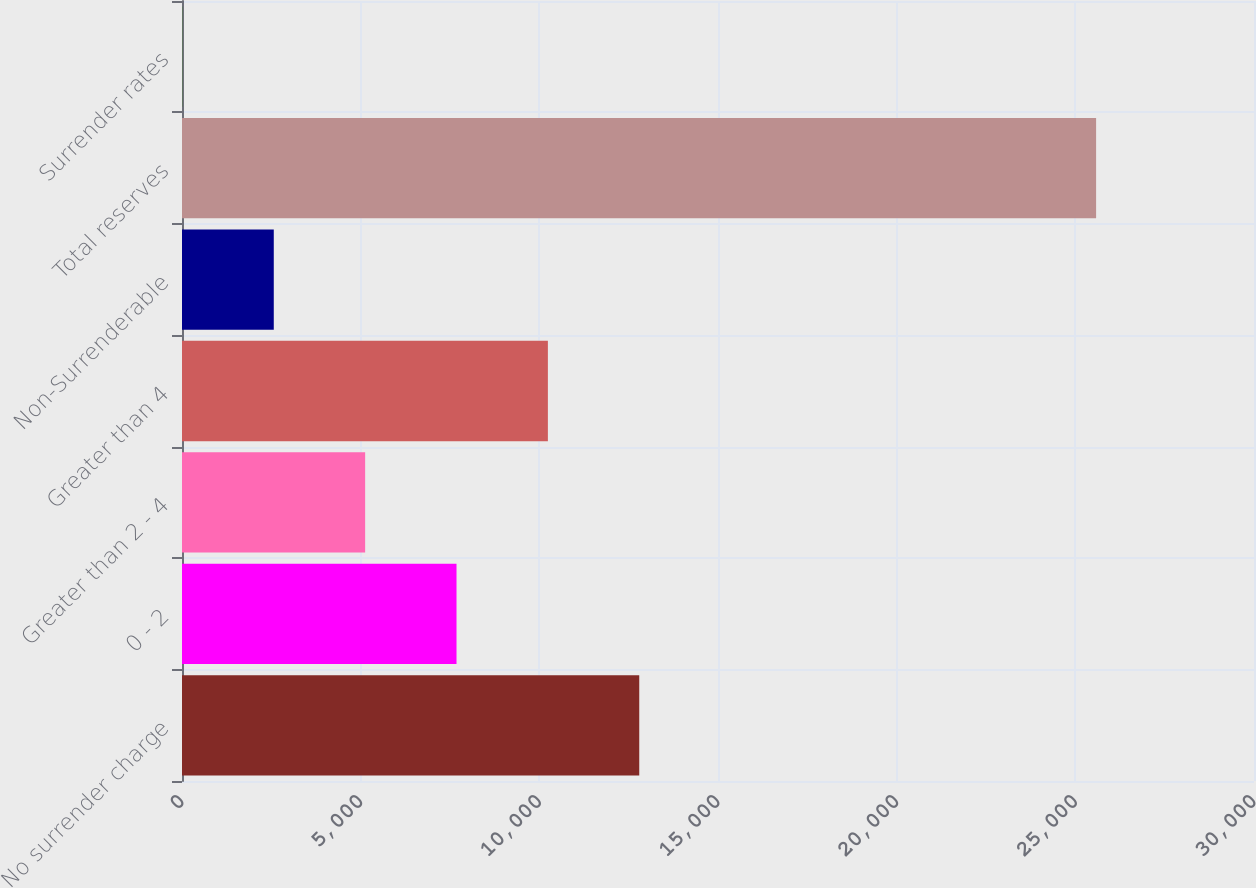<chart> <loc_0><loc_0><loc_500><loc_500><bar_chart><fcel>No surrender charge<fcel>0 - 2<fcel>Greater than 2 - 4<fcel>Greater than 4<fcel>Non-Surrenderable<fcel>Total reserves<fcel>Surrender rates<nl><fcel>12796.2<fcel>7682.28<fcel>5125.32<fcel>10239.2<fcel>2568.36<fcel>25581<fcel>11.4<nl></chart> 